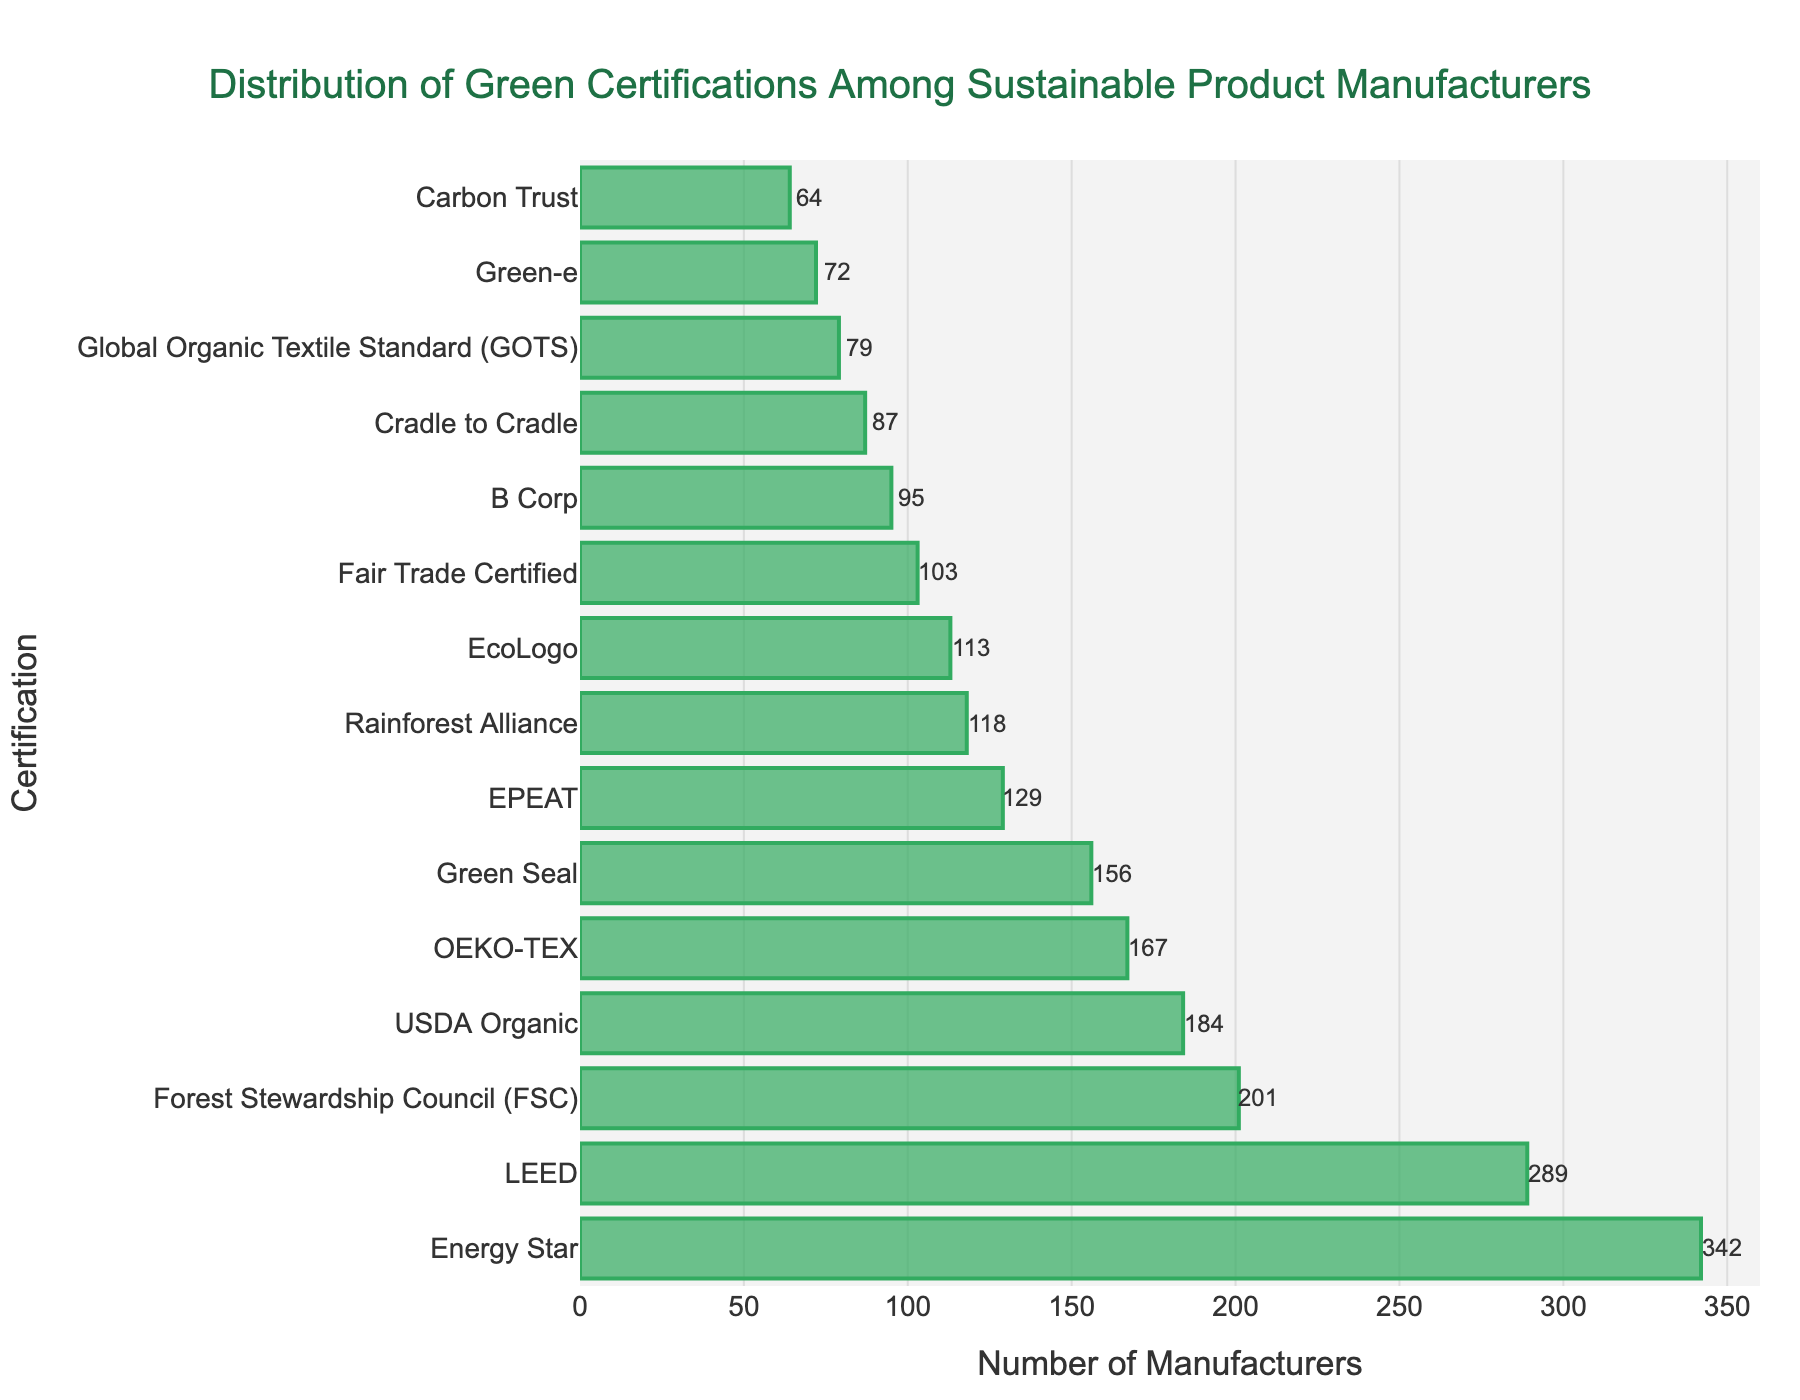Which certification has the highest number of manufacturers? The bar chart shows the number of manufacturers for each certification. The Energy Star bar is the longest, indicating it has the highest number of manufacturers.
Answer: Energy Star Which certification has the fewest number of manufacturers? By observing the bars, Carbon Trust has the shortest bar, indicating the fewest number of manufacturers.
Answer: Carbon Trust How many more manufacturers have Energy Star certification compared to LEED? To find the difference, subtract the number of manufacturers with LEED (289) from those with Energy Star (342). The difference is 342 - 289 = 53.
Answer: 53 Are there more manufacturers with LEED certification or Green Seal certification? By comparing the lengths of the LEED and Green Seal bars, LEED has more manufacturers (289) than Green Seal (156).
Answer: LEED What is the combined total number of manufacturers with EcoLogo and Rainforest Alliance certifications? Add the number of manufacturers for EcoLogo (113) and Rainforest Alliance (118). The total is 113 + 118 = 231.
Answer: 231 Which certifications have fewer than 100 manufacturers? By scanning the bars, Cradle to Cradle (87), Green-e (72), Global Organic Textile Standard (79), Carbon Trust (64), and B Corp (95) have fewer than 100 manufacturers.
Answer: Cradle to Cradle, Green-e, GOTS, Carbon Trust, B Corp Which certifications have more than 200 manufacturers? By checking the bars, Energy Star (342), LEED (289), and Forest Stewardship Council (201) have more than 200 manufacturers.
Answer: Energy Star, LEED, FSC What is the difference between the number of manufacturers with USDA Organic certification and B Corp certification? Subtract the number of manufacturers with B Corp (95) from USDA Organic (184). The difference is 184 - 95 = 89.
Answer: 89 Which certifications have a number of manufacturers closest to the median value for all certifications? First, list all the values: 342, 289, 156, 113, 201, 87, 129, 95, 72, 184, 103, 167, 79, 118, 64. Then sort and find the median value. The sorted list is: 64, 72, 79, 87, 95, 103, 113, 118, 129, 156, 167, 184, 201, 289, 342. The median value (8th in a list of 15 numbers) is 118. The certifications close to 118 manufacturers are EcoLogo (113) and Rainforest Alliance (118).
Answer: EcoLogo, Rainforest Alliance Which certification has the higher number of manufacturers: OEKO-TEX or Fair Trade Certified? By comparing the lengths of the bars, OEKO-TEX has 167 manufacturers, and Fair Trade Certified has 103. Thus, OEKO-TEX has more manufacturers.
Answer: OEKO-TEX 